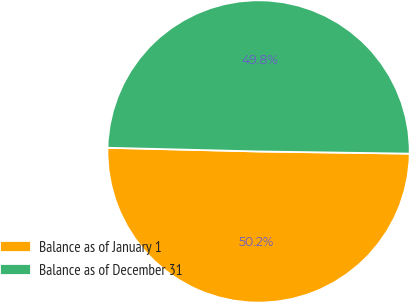Convert chart. <chart><loc_0><loc_0><loc_500><loc_500><pie_chart><fcel>Balance as of January 1<fcel>Balance as of December 31<nl><fcel>50.16%<fcel>49.84%<nl></chart> 